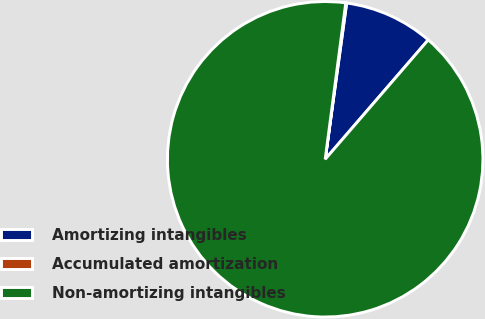Convert chart to OTSL. <chart><loc_0><loc_0><loc_500><loc_500><pie_chart><fcel>Amortizing intangibles<fcel>Accumulated amortization<fcel>Non-amortizing intangibles<nl><fcel>9.16%<fcel>0.09%<fcel>90.75%<nl></chart> 